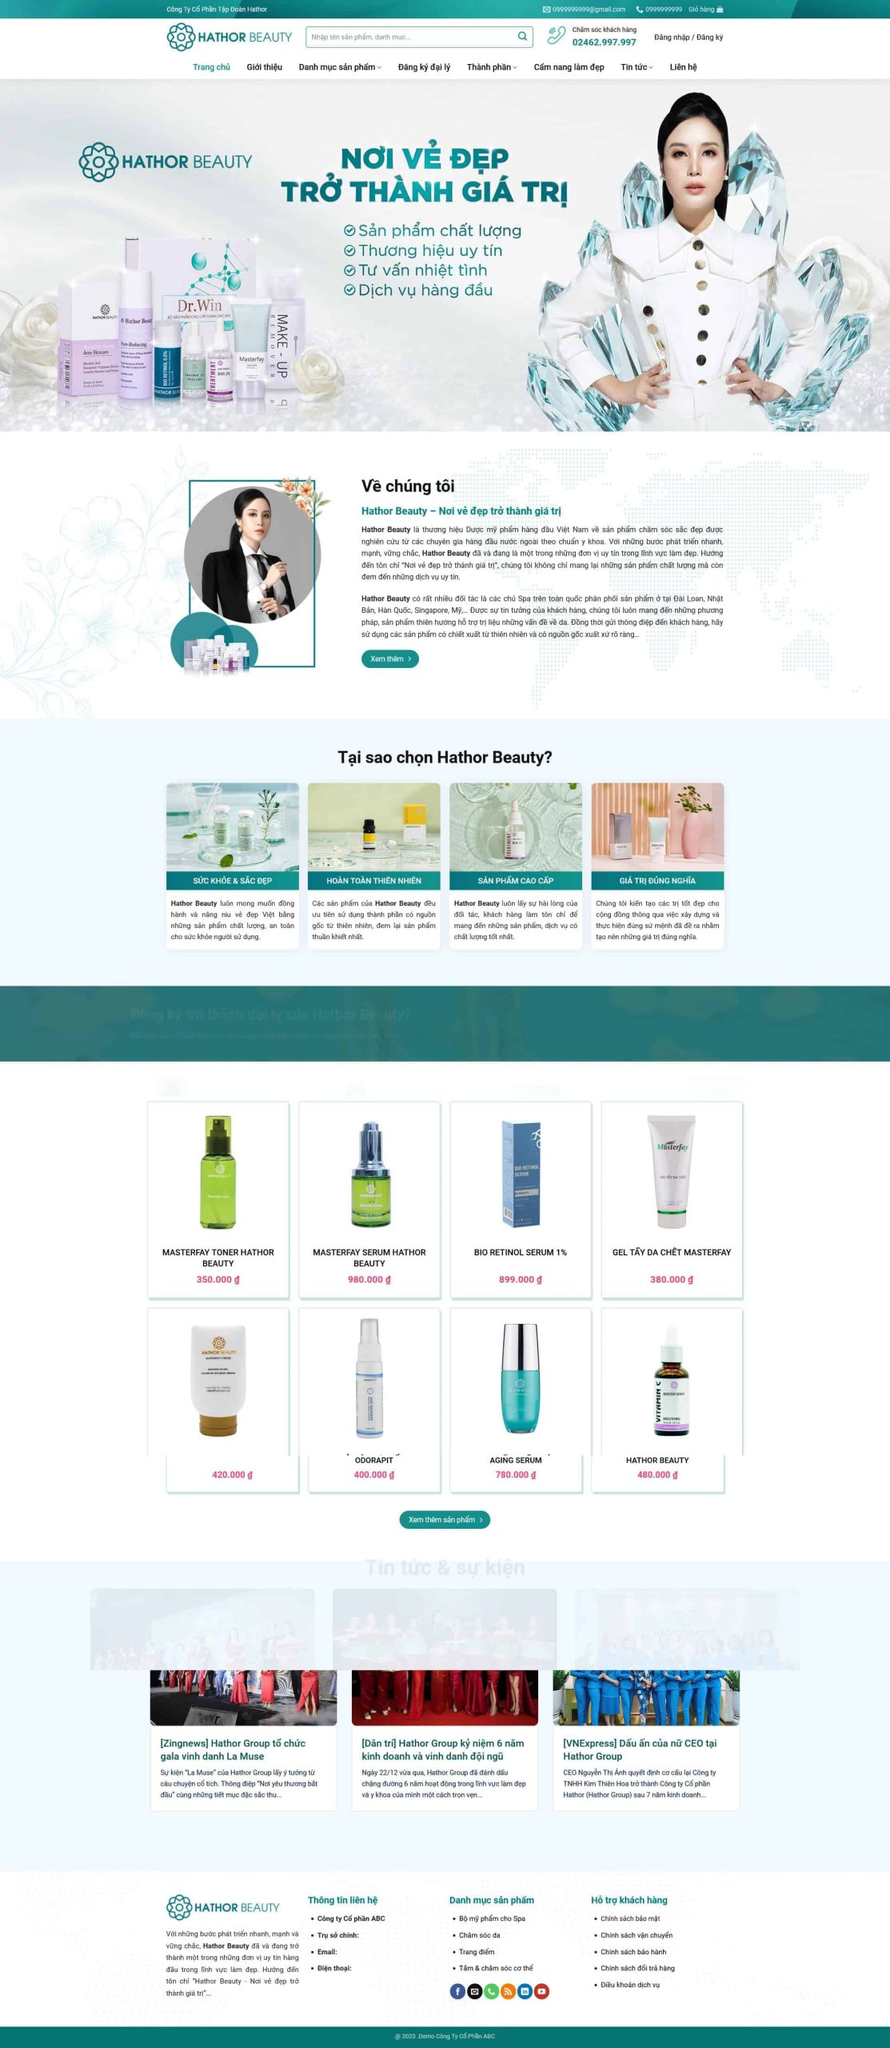Viết một bài viết giới thiệu giao diện website này của DPS MEDIA bao gồm ngành nghề, kiểu dáng, màu sắc, tính năng, bố cục,...Nhưng không nhắc lại liên kết hình ảnh trong bài viết.
 **Giới thiệu giao diện website của DPS MEDIA**

Website của DPS MEDIA mang đến một trải nghiệm trực quan và hấp dẫn dành cho người dùng, đặc biệt là trong ngành làm đẹp. Giao diện website được thiết kế hiện đại, tinh tế, với sự đầu tư kỹ lưỡng về mặt hình ảnh và màu sắc.

**Ngành nghề:**
Website này tập trung vào lĩnh vực làm đẹp, cung cấp các sản phẩm chăm sóc da và mỹ phẩm chất lượng cao. Điều này được thể hiện rõ ràng qua các hình ảnh sản phẩm và nội dung giới thiệu trên trang chủ.

**Kiểu dáng và màu sắc:**
Giao diện website được thiết kế với tông màu chủ đạo là xanh dương và trắng, mang lại cảm giác tươi mới, sạch sẽ và chuyên nghiệp. Các màu sắc này không chỉ tạo cảm giác dễ chịu cho người xem mà còn thể hiện sự tin cậy và chất lượng của thương hiệu. Các khối màu được sắp xếp hài hòa, giúp người dùng dễ dàng tìm kiếm và tiếp cận thông tin.

**Tính năng:**
Website tích hợp nhiều tính năng hữu ích như thanh tìm kiếm sản phẩm, danh mục sản phẩm rõ ràng, và các nút gọi hành động (CTA) như "Xem thêm", "Đăng ký", giúp người dùng dễ dàng thao tác. Ngoài ra, website còn có phần tin tức và sự kiện, cung cấp thông tin mới nhất về các hoạt động của công ty, giúp khách hàng cập nhật kịp thời.

**Bố cục:**
Bố cục của website được sắp xếp một cách logic và hợp lý. Trang chủ hiển thị đầy đủ các phần quan trọng như giới thiệu về công ty, lý do nên chọn sản phẩm, danh mục sản phẩm nổi bật và các bài viết tin tức. Mỗi phần đều có khoảng cách hợp lý, không gây cảm giác chồng chéo hay rối mắt. Phần chân trang cung cấp thông tin liên hệ, hỗ trợ khách hàng và các liên kết mạng xã hội, giúp người dùng có thể kết nối dễ dàng với thương hiệu.

**Tổng kết:**
Website của DPS MEDIA không chỉ thu hút người xem bởi thiết kế đẹp mắt, màu sắc hài hòa mà còn bởi sự tiện lợi và dễ dàng sử dụng. Tất cả các yếu tố từ bố cục, tính năng đến kiểu dáng đều được tối ưu hóa để mang lại trải nghiệm tốt nhất cho người dùng, đặc biệt là những người quan tâm đến lĩnh vực làm đẹp và chăm sóc da. 